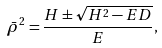Convert formula to latex. <formula><loc_0><loc_0><loc_500><loc_500>\bar { \rho } ^ { 2 } = \frac { H \pm \sqrt { H ^ { 2 } - E D } } { E } ,</formula> 